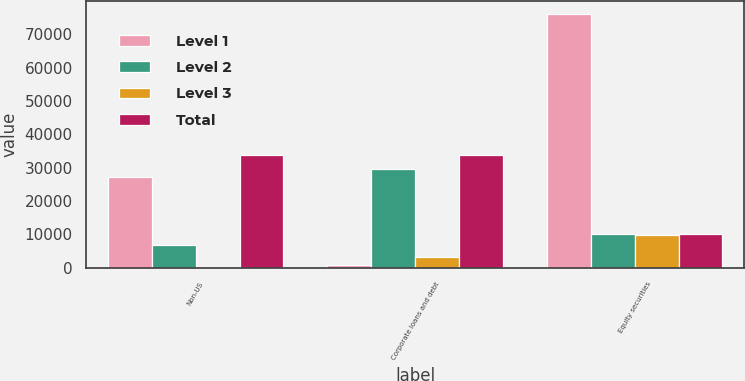Convert chart. <chart><loc_0><loc_0><loc_500><loc_500><stacked_bar_chart><ecel><fcel>Non-US<fcel>Corporate loans and debt<fcel>Equity securities<nl><fcel>Level 1<fcel>27070<fcel>752<fcel>76044<nl><fcel>Level 2<fcel>6882<fcel>29661<fcel>10184<nl><fcel>Level 3<fcel>4<fcel>3270<fcel>9904<nl><fcel>Total<fcel>33956<fcel>33683<fcel>10184<nl></chart> 